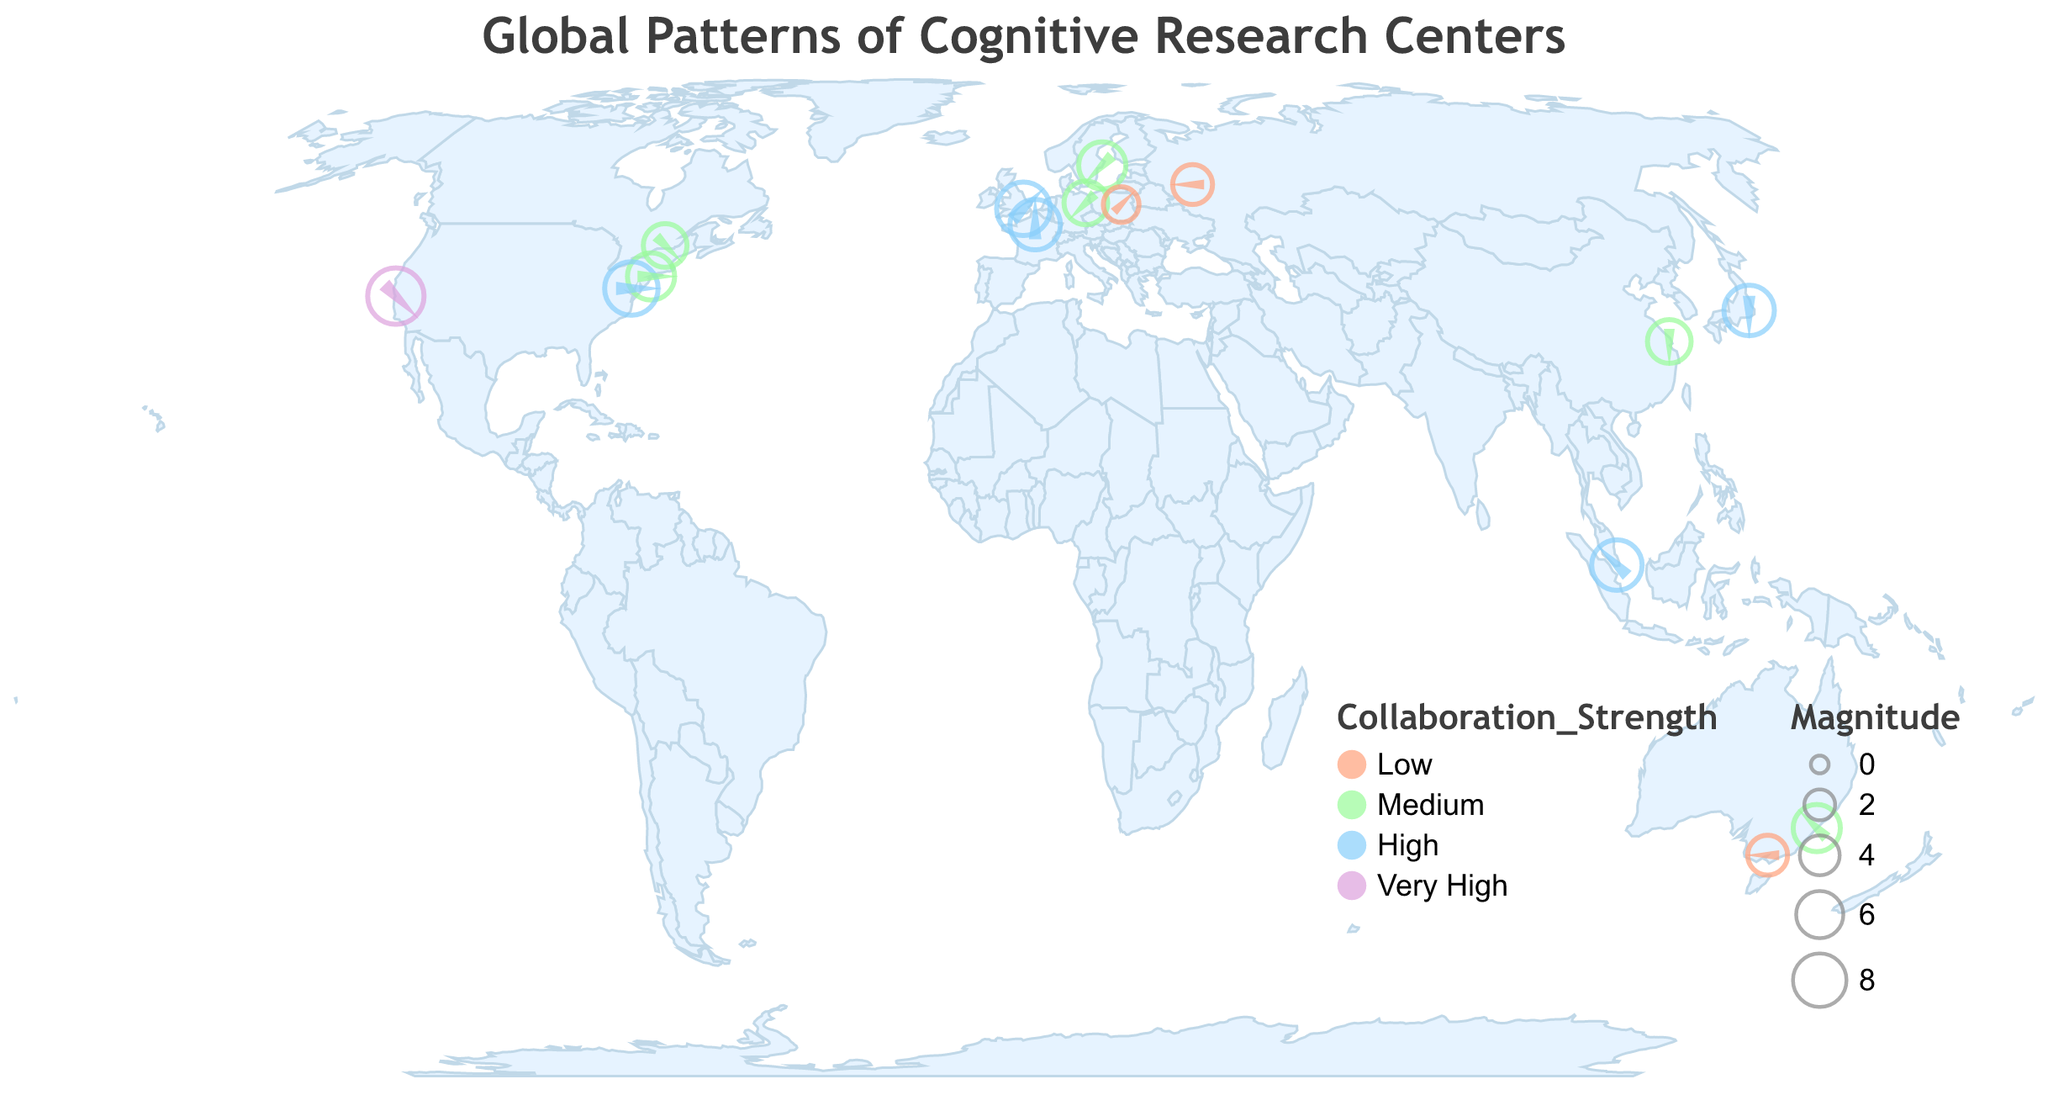How many institutions have a "Very High" collaboration strength? By looking at the color scale used in the plot, institutions with "Very High" collaboration strength are marked in purple. There is only one purple point, which corresponds to Stanford University.
Answer: 1 Which institution has the highest magnitude of collaboration and what is its value? The largest point on the plot represents the institution with the highest magnitude of collaboration. This is Stanford University, with a magnitude of 9.
Answer: Stanford University, 9 What is the direction and magnitude of the collaboration for the University of Sydney? By locating the point for the University of Sydney on the plot, we see that its direction is 315 degrees and its magnitude is 6, marked in light green indicating a medium collaboration strength.
Answer: 315 degrees, 6 Compare the collaboration strengths of the University of Tokyo and Max Planck Institute for Human Development. The color of the points for the University of Tokyo and Max Planck Institute for Human Development represents their collaboration strengths. The University of Tokyo has a high strength (light blue), while Max Planck Institute for Human Development has a medium strength (light green).
Answer: University of Tokyo: High, Max Planck: Medium What is the common direction of collaboration for institutions in Asia based on the data given? Asian institutions on the plot include the University of Tokyo, East China Normal University, and the National University of Singapore. The University of Tokyo has a direction of 180 degrees, East China Normal University has 180 degrees, and the National University of Singapore has 315 degrees. The common direction for two out of three is 180 degrees.
Answer: 180 degrees Which two institutions have the same collaboration magnitude but different collaboration strengths? By observing the size and color of points, the University of Sydney and Karolinska Institute both have a magnitude of 6, but the University of Sydney has a medium strength (light green) and Karolinska Institute also has a medium strength. Also by observing, National University of Singapore and Sorbonne University both have a magnitude of 7 but different strengths (High/Medium).
Answer: University of Sydney, Karolinska Institute and National University of Singapore, Sorbonne University What are the directions of the collaborations for institutions located in North America? North American institutions include New York University, Stanford University, National Institutes of Health, and McGill University. Their respective directions are 90 degrees, 135 degrees, 90 degrees, and 135 degrees.
Answer: New York University: 90 degrees, Stanford University: 135 degrees, NIH: 90 degrees, McGill University: 135 degrees Calculate the average magnitude of collaboration for institutions with "Low" collaboration strength. Institutions with a "Low" collaboration strength are Moscow State University, University of Melbourne, and University of Warsaw. Their magnitudes are 4, 4, and 3 respectively. The average is calculated as (4 + 4 + 3) / 3 = 11 / 3 = 3.67.
Answer: 3.67 Which institution in Europe has the highest magnitude of collaboration, and what is its value? By observing the plot, Stanford University in the USA has the highest value overall, but within Europe specifically, Sorbonne University has the highest magnitude of 7.
Answer: Sorbonne University, 7 What pattern can be observed between the geographical location and direction of collaboration of institutions near the prime meridian (0 degrees longitude)? Institutions close to the prime meridian include University College London and Sorbonne University. Both have different collaboration directions, with University College London at 45 degrees and Sorbonne University at 0 degrees. Thus, there’s no common pattern.
Answer: No common pattern 